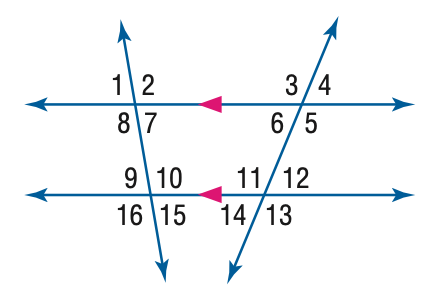Answer the mathemtical geometry problem and directly provide the correct option letter.
Question: In the figure, m \angle 8 = 96 and m \angle 12 = 42. Find the measure of \angle 9.
Choices: A: 42 B: 84 C: 94 D: 96 B 